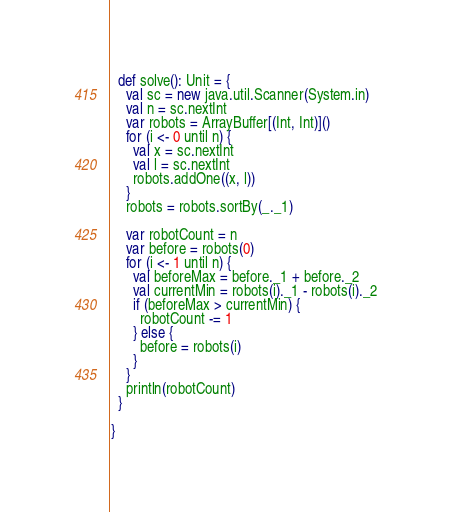Convert code to text. <code><loc_0><loc_0><loc_500><loc_500><_Scala_>  def solve(): Unit = {
    val sc = new java.util.Scanner(System.in)
    val n = sc.nextInt
    var robots = ArrayBuffer[(Int, Int)]()
    for (i <- 0 until n) {
      val x = sc.nextInt
      val l = sc.nextInt
      robots.addOne((x, l))
    }
    robots = robots.sortBy(_._1)

    var robotCount = n
    var before = robots(0)
    for (i <- 1 until n) {
      val beforeMax = before._1 + before._2
      val currentMin = robots(i)._1 - robots(i)._2
      if (beforeMax > currentMin) {
        robotCount -= 1
      } else {
        before = robots(i)
      }
    }
    println(robotCount)
  }

}
</code> 